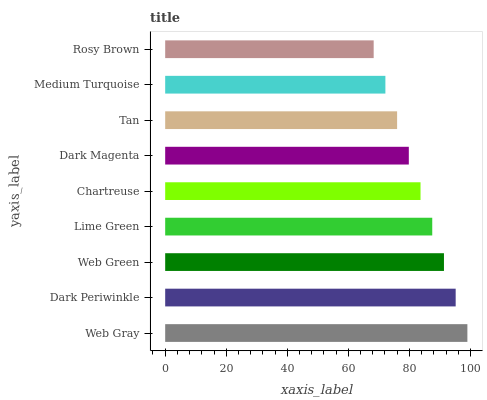Is Rosy Brown the minimum?
Answer yes or no. Yes. Is Web Gray the maximum?
Answer yes or no. Yes. Is Dark Periwinkle the minimum?
Answer yes or no. No. Is Dark Periwinkle the maximum?
Answer yes or no. No. Is Web Gray greater than Dark Periwinkle?
Answer yes or no. Yes. Is Dark Periwinkle less than Web Gray?
Answer yes or no. Yes. Is Dark Periwinkle greater than Web Gray?
Answer yes or no. No. Is Web Gray less than Dark Periwinkle?
Answer yes or no. No. Is Chartreuse the high median?
Answer yes or no. Yes. Is Chartreuse the low median?
Answer yes or no. Yes. Is Tan the high median?
Answer yes or no. No. Is Tan the low median?
Answer yes or no. No. 